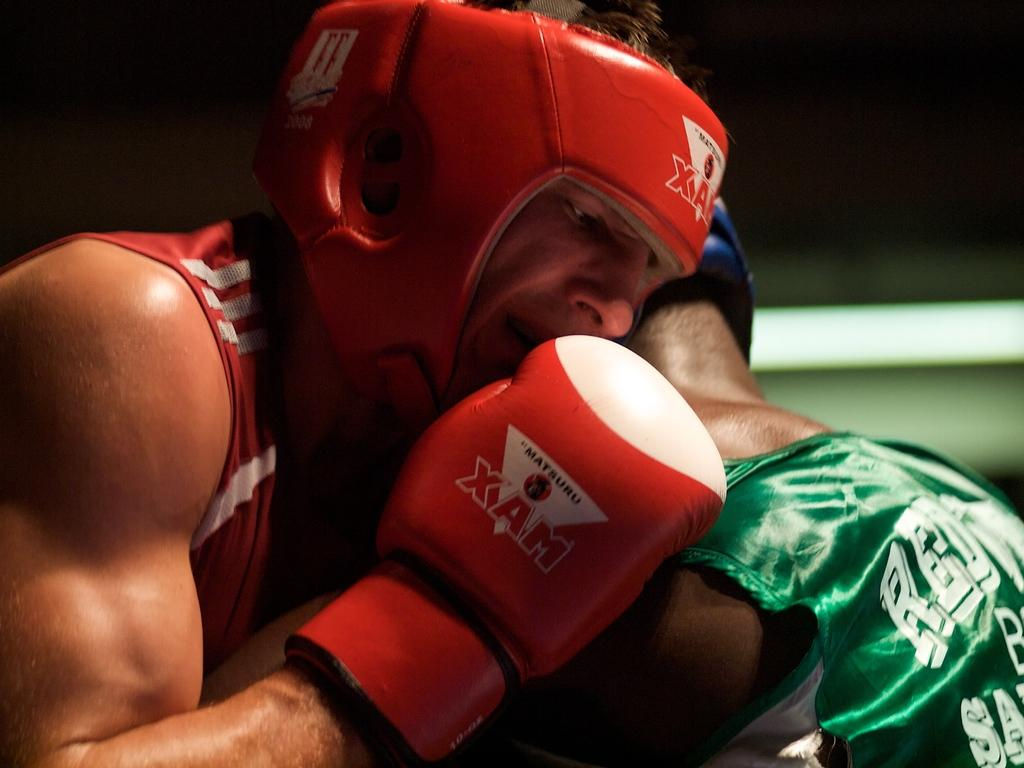<image>
Create a compact narrative representing the image presented. a boxing match with the word XAM on the gloves 